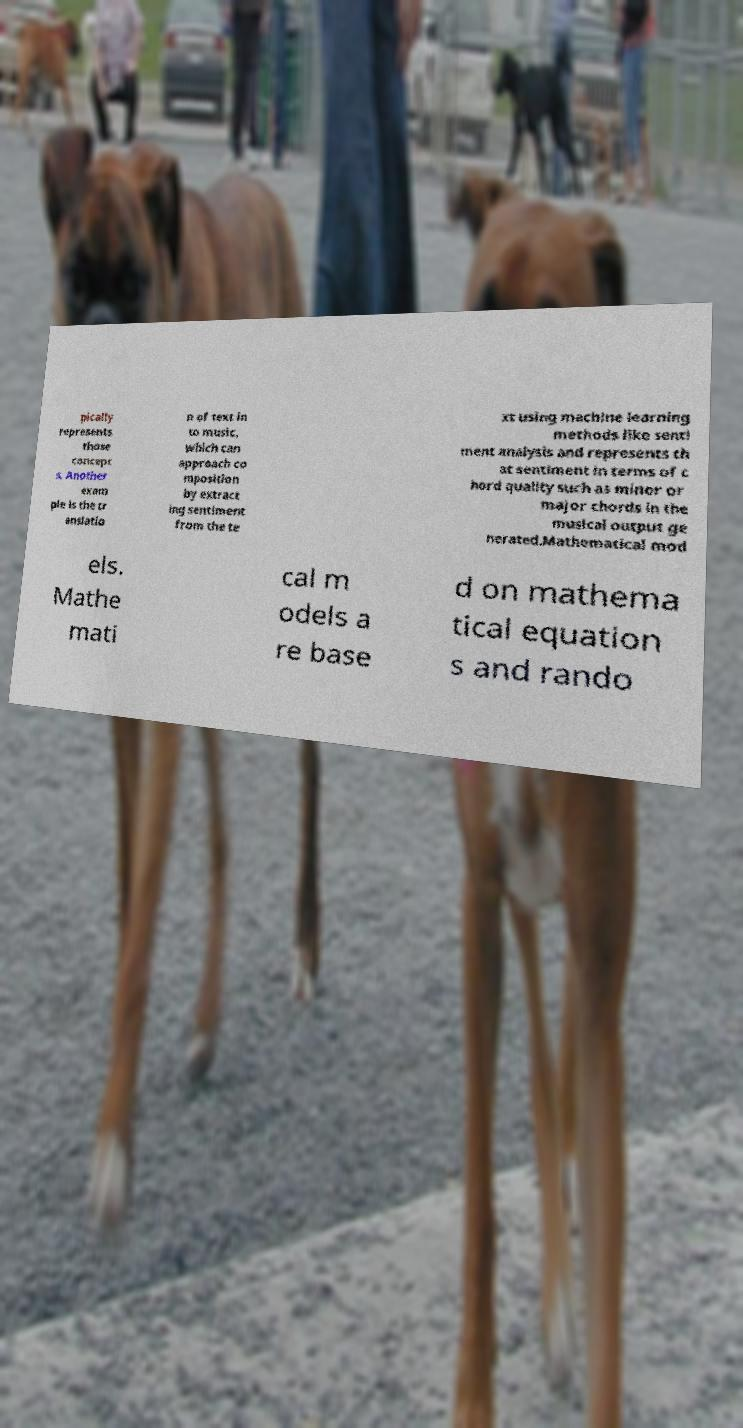Could you assist in decoding the text presented in this image and type it out clearly? pically represents those concept s. Another exam ple is the tr anslatio n of text in to music, which can approach co mposition by extract ing sentiment from the te xt using machine learning methods like senti ment analysis and represents th at sentiment in terms of c hord quality such as minor or major chords in the musical output ge nerated.Mathematical mod els. Mathe mati cal m odels a re base d on mathema tical equation s and rando 